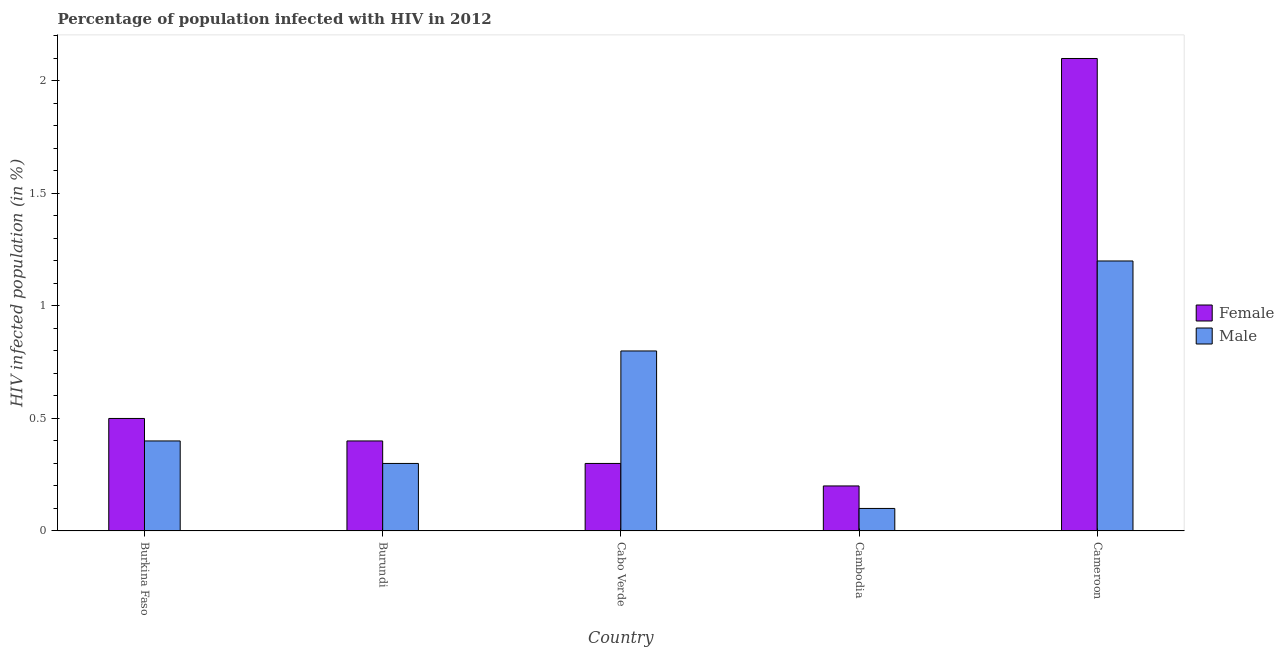How many different coloured bars are there?
Your answer should be compact. 2. Are the number of bars on each tick of the X-axis equal?
Your answer should be very brief. Yes. How many bars are there on the 1st tick from the left?
Your answer should be very brief. 2. How many bars are there on the 1st tick from the right?
Keep it short and to the point. 2. What is the label of the 4th group of bars from the left?
Your answer should be very brief. Cambodia. Across all countries, what is the maximum percentage of males who are infected with hiv?
Ensure brevity in your answer.  1.2. In which country was the percentage of females who are infected with hiv maximum?
Your response must be concise. Cameroon. In which country was the percentage of females who are infected with hiv minimum?
Provide a short and direct response. Cambodia. What is the total percentage of males who are infected with hiv in the graph?
Make the answer very short. 2.8. What is the difference between the percentage of males who are infected with hiv in Burundi and that in Cameroon?
Provide a short and direct response. -0.9. What is the difference between the percentage of females who are infected with hiv in Cambodia and the percentage of males who are infected with hiv in Cameroon?
Keep it short and to the point. -1. What is the average percentage of males who are infected with hiv per country?
Your response must be concise. 0.56. What is the difference between the percentage of females who are infected with hiv and percentage of males who are infected with hiv in Burkina Faso?
Make the answer very short. 0.1. In how many countries, is the percentage of males who are infected with hiv greater than 0.30000000000000004 %?
Your answer should be compact. 3. What is the ratio of the percentage of males who are infected with hiv in Cambodia to that in Cameroon?
Offer a very short reply. 0.08. Is the percentage of females who are infected with hiv in Burundi less than that in Cabo Verde?
Give a very brief answer. No. What is the difference between the highest and the second highest percentage of males who are infected with hiv?
Your answer should be compact. 0.4. What is the difference between the highest and the lowest percentage of males who are infected with hiv?
Your response must be concise. 1.1. In how many countries, is the percentage of females who are infected with hiv greater than the average percentage of females who are infected with hiv taken over all countries?
Provide a succinct answer. 1. What does the 1st bar from the left in Burkina Faso represents?
Your answer should be compact. Female. How many bars are there?
Provide a succinct answer. 10. What is the difference between two consecutive major ticks on the Y-axis?
Your response must be concise. 0.5. Where does the legend appear in the graph?
Provide a succinct answer. Center right. How are the legend labels stacked?
Make the answer very short. Vertical. What is the title of the graph?
Give a very brief answer. Percentage of population infected with HIV in 2012. Does "Residents" appear as one of the legend labels in the graph?
Make the answer very short. No. What is the label or title of the X-axis?
Keep it short and to the point. Country. What is the label or title of the Y-axis?
Provide a succinct answer. HIV infected population (in %). What is the HIV infected population (in %) of Female in Burkina Faso?
Provide a short and direct response. 0.5. What is the HIV infected population (in %) of Female in Burundi?
Offer a very short reply. 0.4. What is the HIV infected population (in %) in Male in Burundi?
Offer a terse response. 0.3. What is the HIV infected population (in %) of Female in Cabo Verde?
Give a very brief answer. 0.3. What is the HIV infected population (in %) of Male in Cabo Verde?
Provide a succinct answer. 0.8. What is the HIV infected population (in %) of Female in Cambodia?
Your response must be concise. 0.2. Across all countries, what is the maximum HIV infected population (in %) of Female?
Offer a terse response. 2.1. Across all countries, what is the maximum HIV infected population (in %) in Male?
Give a very brief answer. 1.2. Across all countries, what is the minimum HIV infected population (in %) of Female?
Keep it short and to the point. 0.2. Across all countries, what is the minimum HIV infected population (in %) in Male?
Keep it short and to the point. 0.1. What is the difference between the HIV infected population (in %) of Female in Burkina Faso and that in Burundi?
Keep it short and to the point. 0.1. What is the difference between the HIV infected population (in %) in Female in Burkina Faso and that in Cabo Verde?
Your answer should be compact. 0.2. What is the difference between the HIV infected population (in %) of Male in Burkina Faso and that in Cabo Verde?
Give a very brief answer. -0.4. What is the difference between the HIV infected population (in %) in Male in Burkina Faso and that in Cambodia?
Ensure brevity in your answer.  0.3. What is the difference between the HIV infected population (in %) of Female in Burkina Faso and that in Cameroon?
Offer a very short reply. -1.6. What is the difference between the HIV infected population (in %) of Male in Burundi and that in Cabo Verde?
Your answer should be very brief. -0.5. What is the difference between the HIV infected population (in %) in Female in Burundi and that in Cambodia?
Offer a very short reply. 0.2. What is the difference between the HIV infected population (in %) in Male in Burundi and that in Cameroon?
Keep it short and to the point. -0.9. What is the difference between the HIV infected population (in %) of Female in Cabo Verde and that in Cameroon?
Your answer should be compact. -1.8. What is the difference between the HIV infected population (in %) in Female in Burkina Faso and the HIV infected population (in %) in Male in Cambodia?
Offer a terse response. 0.4. What is the difference between the HIV infected population (in %) in Female in Burkina Faso and the HIV infected population (in %) in Male in Cameroon?
Your response must be concise. -0.7. What is the difference between the HIV infected population (in %) in Female in Burundi and the HIV infected population (in %) in Male in Cabo Verde?
Your answer should be compact. -0.4. What is the difference between the HIV infected population (in %) in Female in Cabo Verde and the HIV infected population (in %) in Male in Cameroon?
Provide a succinct answer. -0.9. What is the difference between the HIV infected population (in %) in Female in Cambodia and the HIV infected population (in %) in Male in Cameroon?
Provide a short and direct response. -1. What is the average HIV infected population (in %) of Male per country?
Provide a succinct answer. 0.56. What is the difference between the HIV infected population (in %) in Female and HIV infected population (in %) in Male in Burkina Faso?
Your answer should be very brief. 0.1. What is the difference between the HIV infected population (in %) of Female and HIV infected population (in %) of Male in Burundi?
Your answer should be compact. 0.1. What is the difference between the HIV infected population (in %) of Female and HIV infected population (in %) of Male in Cabo Verde?
Provide a short and direct response. -0.5. What is the ratio of the HIV infected population (in %) in Female in Burkina Faso to that in Burundi?
Make the answer very short. 1.25. What is the ratio of the HIV infected population (in %) of Male in Burkina Faso to that in Cabo Verde?
Make the answer very short. 0.5. What is the ratio of the HIV infected population (in %) in Male in Burkina Faso to that in Cambodia?
Your answer should be compact. 4. What is the ratio of the HIV infected population (in %) in Female in Burkina Faso to that in Cameroon?
Your answer should be compact. 0.24. What is the ratio of the HIV infected population (in %) of Male in Burkina Faso to that in Cameroon?
Provide a succinct answer. 0.33. What is the ratio of the HIV infected population (in %) of Male in Burundi to that in Cabo Verde?
Ensure brevity in your answer.  0.38. What is the ratio of the HIV infected population (in %) in Female in Burundi to that in Cambodia?
Your answer should be very brief. 2. What is the ratio of the HIV infected population (in %) in Male in Burundi to that in Cambodia?
Make the answer very short. 3. What is the ratio of the HIV infected population (in %) in Female in Burundi to that in Cameroon?
Give a very brief answer. 0.19. What is the ratio of the HIV infected population (in %) of Male in Burundi to that in Cameroon?
Your response must be concise. 0.25. What is the ratio of the HIV infected population (in %) in Male in Cabo Verde to that in Cambodia?
Offer a terse response. 8. What is the ratio of the HIV infected population (in %) of Female in Cabo Verde to that in Cameroon?
Your answer should be very brief. 0.14. What is the ratio of the HIV infected population (in %) of Female in Cambodia to that in Cameroon?
Your answer should be compact. 0.1. What is the ratio of the HIV infected population (in %) in Male in Cambodia to that in Cameroon?
Provide a short and direct response. 0.08. What is the difference between the highest and the second highest HIV infected population (in %) in Female?
Your response must be concise. 1.6. What is the difference between the highest and the second highest HIV infected population (in %) in Male?
Offer a terse response. 0.4. What is the difference between the highest and the lowest HIV infected population (in %) of Female?
Offer a very short reply. 1.9. 